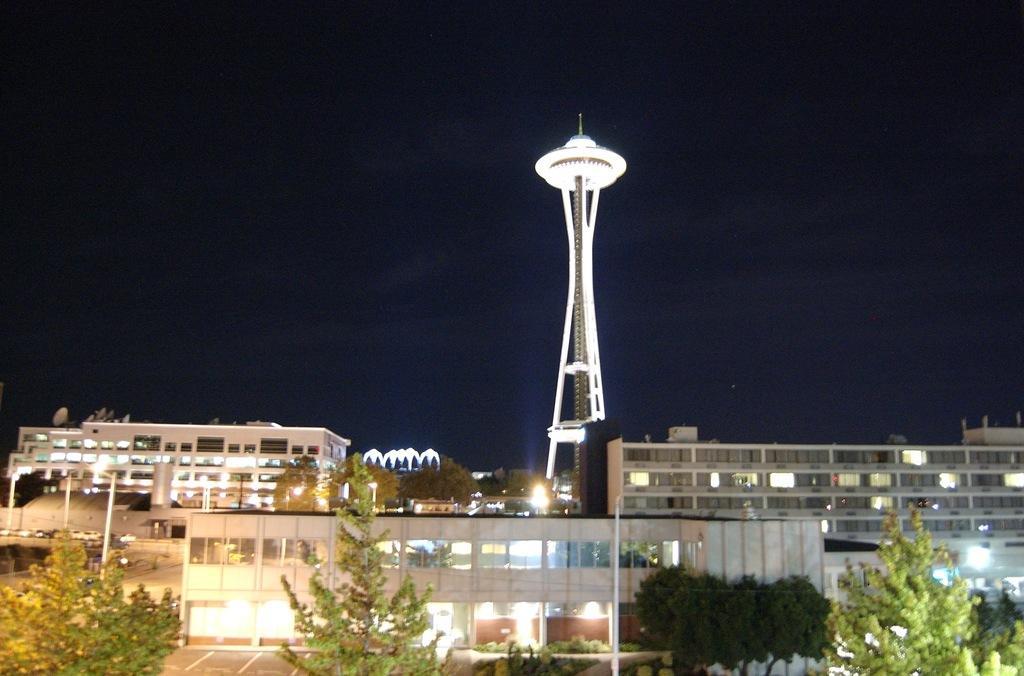Could you give a brief overview of what you see in this image? In this image there are buildings. In the center there is a tower and we can see trees. In the background there is sky. 